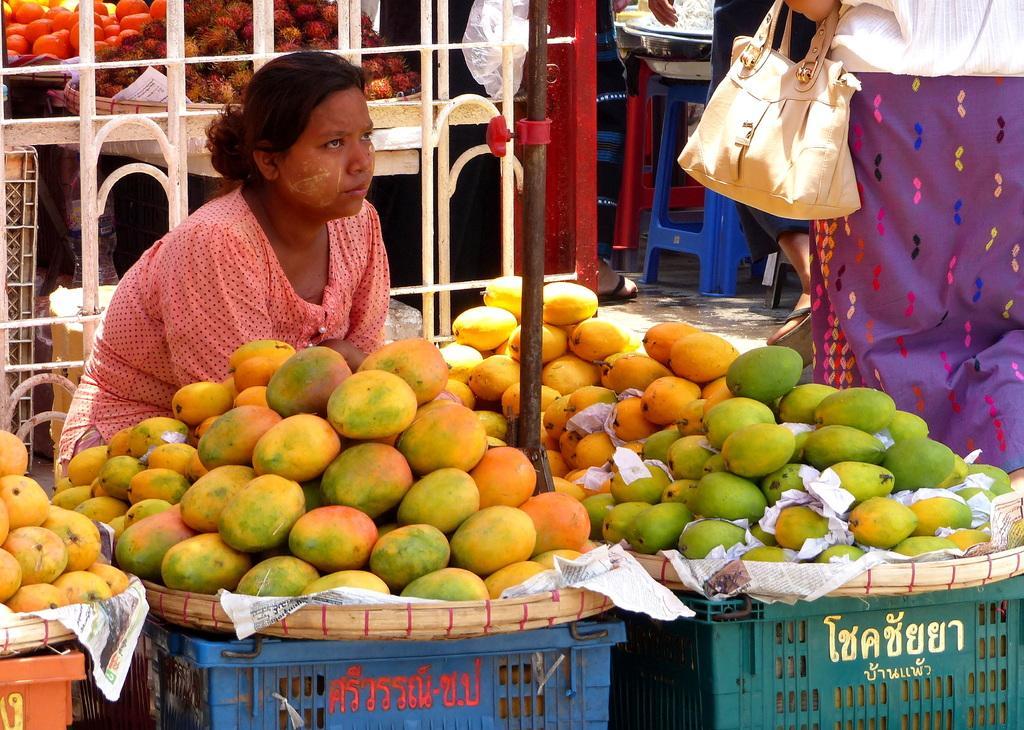Could you give a brief overview of what you see in this image? In this picture we observe a woman and in front of her there are baskets of mangoes kept on a stand. In the background we observe many vegetables kept in a basket and also people in the frame. 